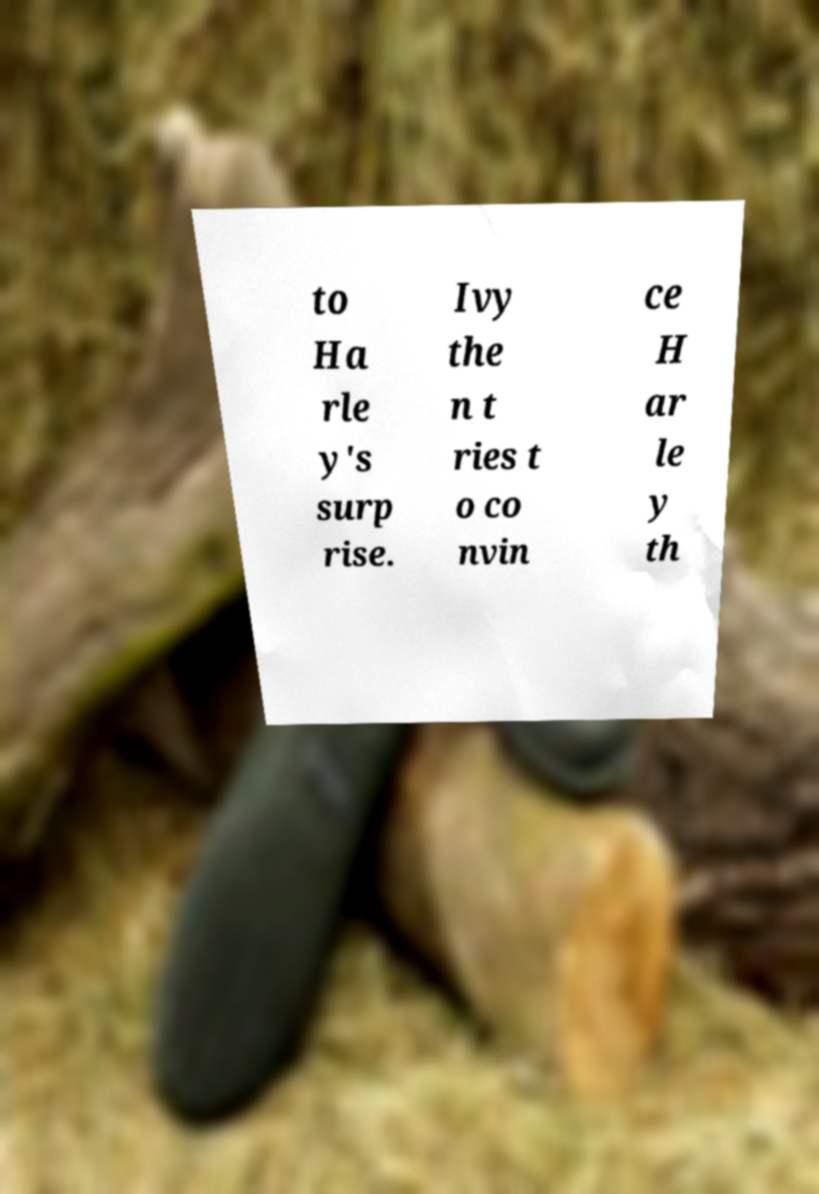Could you extract and type out the text from this image? to Ha rle y's surp rise. Ivy the n t ries t o co nvin ce H ar le y th 